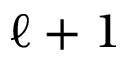Convert formula to latex. <formula><loc_0><loc_0><loc_500><loc_500>{ \ell + 1 }</formula> 